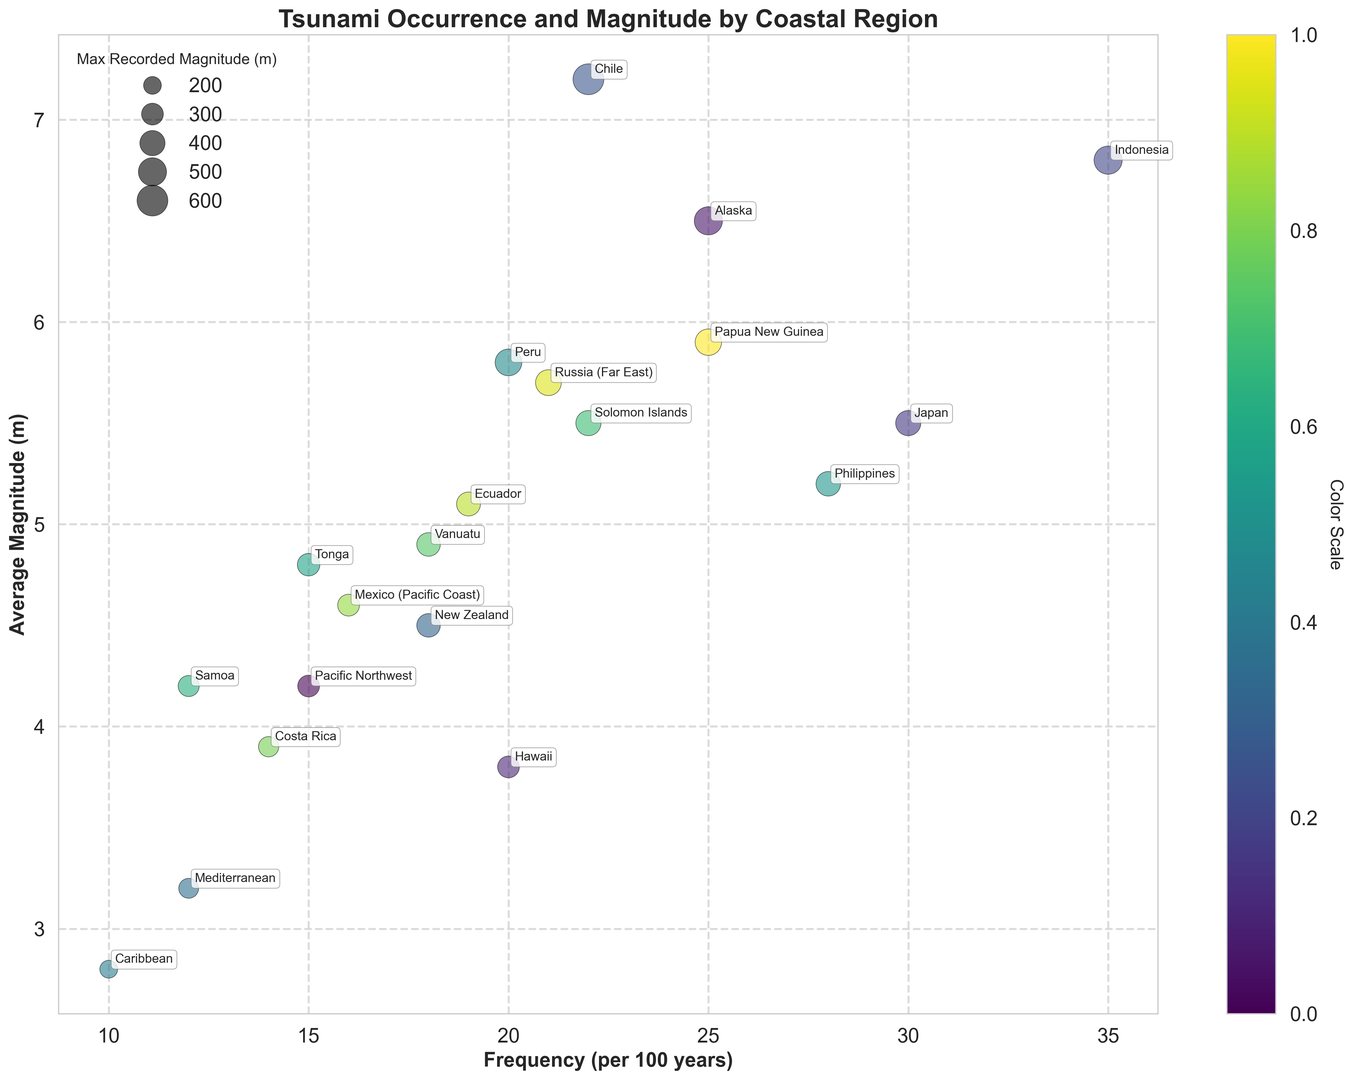What region experiences the highest frequency of tsunamis? The region with the highest position on the x-axis represents the highest frequency. By looking at the x-axis, Indonesia has the highest frequency of tsunamis at 35 per 100 years.
Answer: Indonesia Which region has the largest recorded magnitude of a tsunami? The regions are represented by the size of the bubbles. The largest bubble indicates the highest recorded magnitude. By looking at the figure, Chile has the largest bubble, representing a maximum recorded magnitude of 60 meters.
Answer: Chile Compare the average magnitudes of tsunamis in Japan and the Philippines. Which is higher? To compare, look at the y-axis values for Japan and the Philippines. Japan is at 5.5 meters and the Philippines is at 5.2 meters. Thus, Japan has a higher average magnitude.
Answer: Japan Which regions have a maximum recorded magnitude of 50 meters? The color scale and bubble sizes indicate the maximum recorded magnitude. Both Alaska and Indonesia have similar large bubble sizes representing a maximum recorded magnitude of 50 meters.
Answer: Alaska and Indonesia What is the total frequency of tsunamis in New Zealand and Tonga? New Zealand has a frequency of 18 and Tonga has a frequency of 15. Adding these together: 18 + 15 = 33.
Answer: 33 How does the average magnitude of tsunamis in the Caribbean compare to that in the Mediterranean? The y-axis values show the average magnitude. The Caribbean's value is 2.8 meters, while the Mediterranean's value is 3.2 meters. Hence, the Mediterranean has a higher average magnitude.
Answer: Mediterranean Which region has an average magnitude of around 6 meters and a frequency of over 20 per 100 years? By examining the bubbles near the 6-meter mark on the y-axis and those with x-values over 20, Papua New Guinea fits the description, having an average of 5.9 meters and frequency of 25.
Answer: Papua New Guinea How much higher is the maximum recorded magnitude in Chile compared to that in Russia (Far East)? Chile's maximum recorded magnitude is 60 meters, and Russia (Far East)'s is 42 meters. The difference is 60 - 42 = 18 meters.
Answer: 18 meters What regions have an average magnitude below 4 meters but a frequency of over 10 per 100 years? Regions with y-values below 4 meters in combination with x-values over 10 per 100 years include Hawaii, Mediterranean, and Caribbean.
Answer: Hawaii, Mediterranean, and Caribbean Sort the maximum recorded magnitudes of tsunamis in descending order for Alaska, Peru, and Vanuatu. The maximum recorded magnitudes are Alaska (50 meters), Peru (45 meters), and Vanuatu (35 meters) when sorted in descending order it is 50, 45, and 35 meters respectively.
Answer: 50, 45, 35 meters 